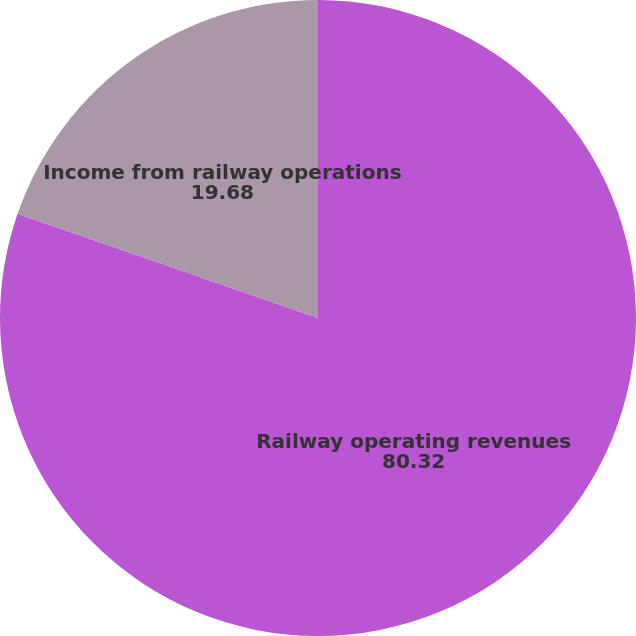Convert chart to OTSL. <chart><loc_0><loc_0><loc_500><loc_500><pie_chart><fcel>Railway operating revenues<fcel>Income from railway operations<nl><fcel>80.32%<fcel>19.68%<nl></chart> 